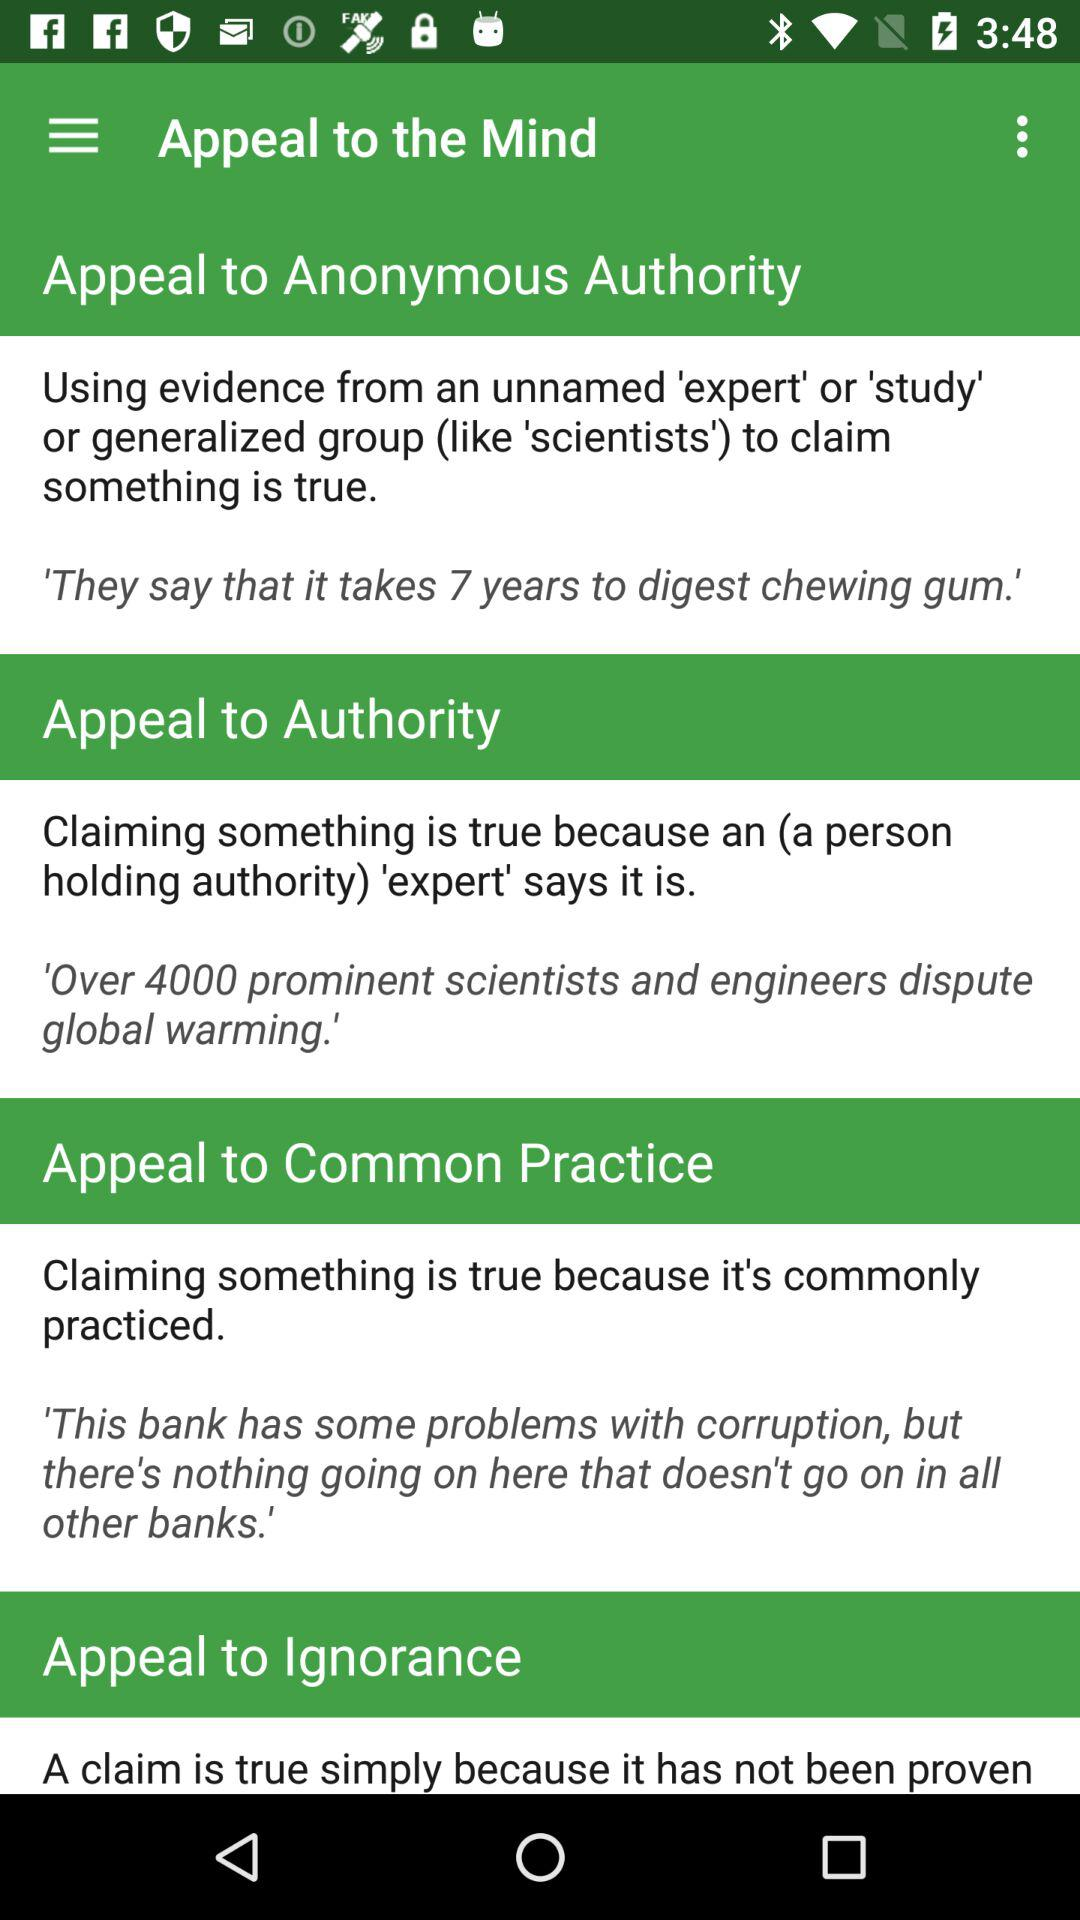Who is this application powered by?
When the provided information is insufficient, respond with <no answer>. <no answer> 